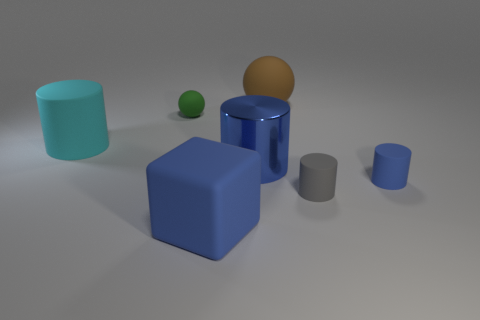How many things are either cylinders that are to the right of the large ball or small purple rubber objects?
Offer a terse response. 2. What is the color of the big ball that is made of the same material as the cube?
Keep it short and to the point. Brown. Is there a green rubber sphere that has the same size as the gray rubber thing?
Keep it short and to the point. Yes. Does the big cylinder right of the green matte object have the same color as the large matte block?
Your answer should be compact. Yes. The big matte thing that is both behind the gray cylinder and left of the large brown ball is what color?
Your answer should be very brief. Cyan. The gray object that is the same size as the green object is what shape?
Provide a succinct answer. Cylinder. Are there any other metallic things of the same shape as the gray object?
Your answer should be compact. Yes. Is the size of the blue matte thing that is to the right of the brown thing the same as the small gray thing?
Provide a short and direct response. Yes. There is a matte thing that is in front of the tiny blue thing and right of the brown ball; what size is it?
Give a very brief answer. Small. What number of other things are made of the same material as the brown ball?
Ensure brevity in your answer.  5. 